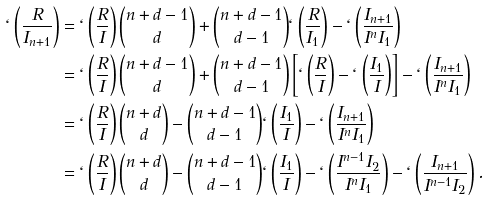Convert formula to latex. <formula><loc_0><loc_0><loc_500><loc_500>\ell \left ( \frac { R } { I _ { n + 1 } } \right ) & = \ell \left ( \frac { R } { I } \right ) { n + d - 1 \choose d } + { n + d - 1 \choose d - 1 } \ell \left ( \frac { R } { I _ { 1 } } \right ) - \ell \left ( \frac { I _ { n + 1 } } { I ^ { n } I _ { 1 } } \right ) \\ & = \ell \left ( \frac { R } { I } \right ) { n + d - 1 \choose d } + { n + d - 1 \choose d - 1 } \left [ \ell \left ( \frac { R } { I } \right ) - \ell \left ( \frac { I _ { 1 } } { I } \right ) \right ] - \ell \left ( \frac { I _ { n + 1 } } { I ^ { n } I _ { 1 } } \right ) \\ & = \ell \left ( \frac { R } { I } \right ) { n + d \choose d } - { n + d - 1 \choose d - 1 } \ell \left ( \frac { I _ { 1 } } { I } \right ) - \ell \left ( \frac { I _ { n + 1 } } { I ^ { n } I _ { 1 } } \right ) \\ & = \ell \left ( \frac { R } { I } \right ) { n + d \choose d } - { n + d - 1 \choose d - 1 } \ell \left ( \frac { I _ { 1 } } { I } \right ) - \ell \left ( \frac { I ^ { n - 1 } I _ { 2 } } { I ^ { n } I _ { 1 } } \right ) - \ell \left ( \frac { I _ { n + 1 } } { I ^ { n - 1 } I _ { 2 } } \right ) .</formula> 